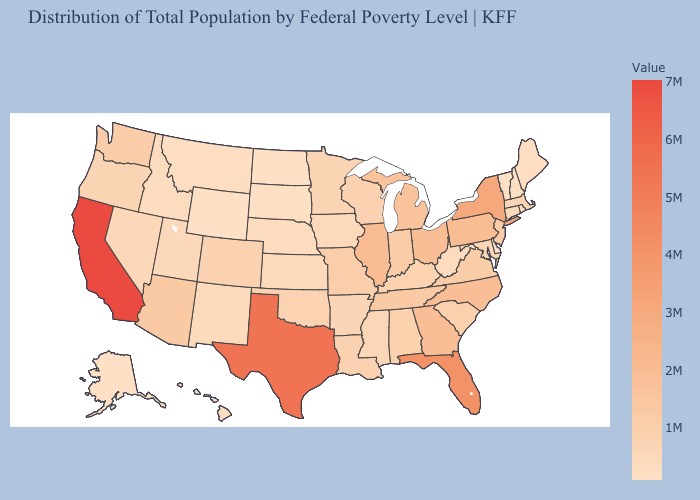Which states have the lowest value in the Northeast?
Concise answer only. Vermont. Among the states that border California , which have the lowest value?
Give a very brief answer. Nevada. Which states hav the highest value in the Northeast?
Keep it brief. New York. Is the legend a continuous bar?
Keep it brief. Yes. Does the map have missing data?
Write a very short answer. No. Which states have the lowest value in the South?
Keep it brief. Delaware. Does North Carolina have the highest value in the South?
Concise answer only. No. Among the states that border Washington , which have the lowest value?
Keep it brief. Idaho. 